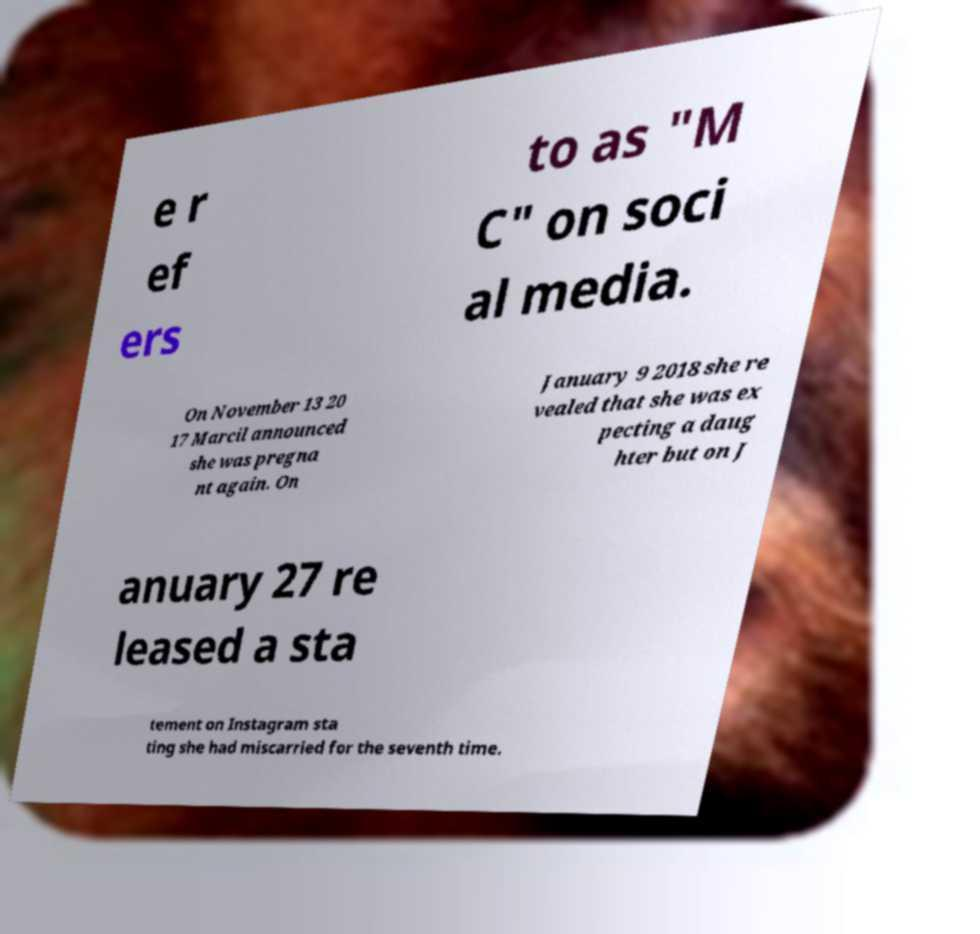Please identify and transcribe the text found in this image. e r ef ers to as "M C" on soci al media. On November 13 20 17 Marcil announced she was pregna nt again. On January 9 2018 she re vealed that she was ex pecting a daug hter but on J anuary 27 re leased a sta tement on Instagram sta ting she had miscarried for the seventh time. 